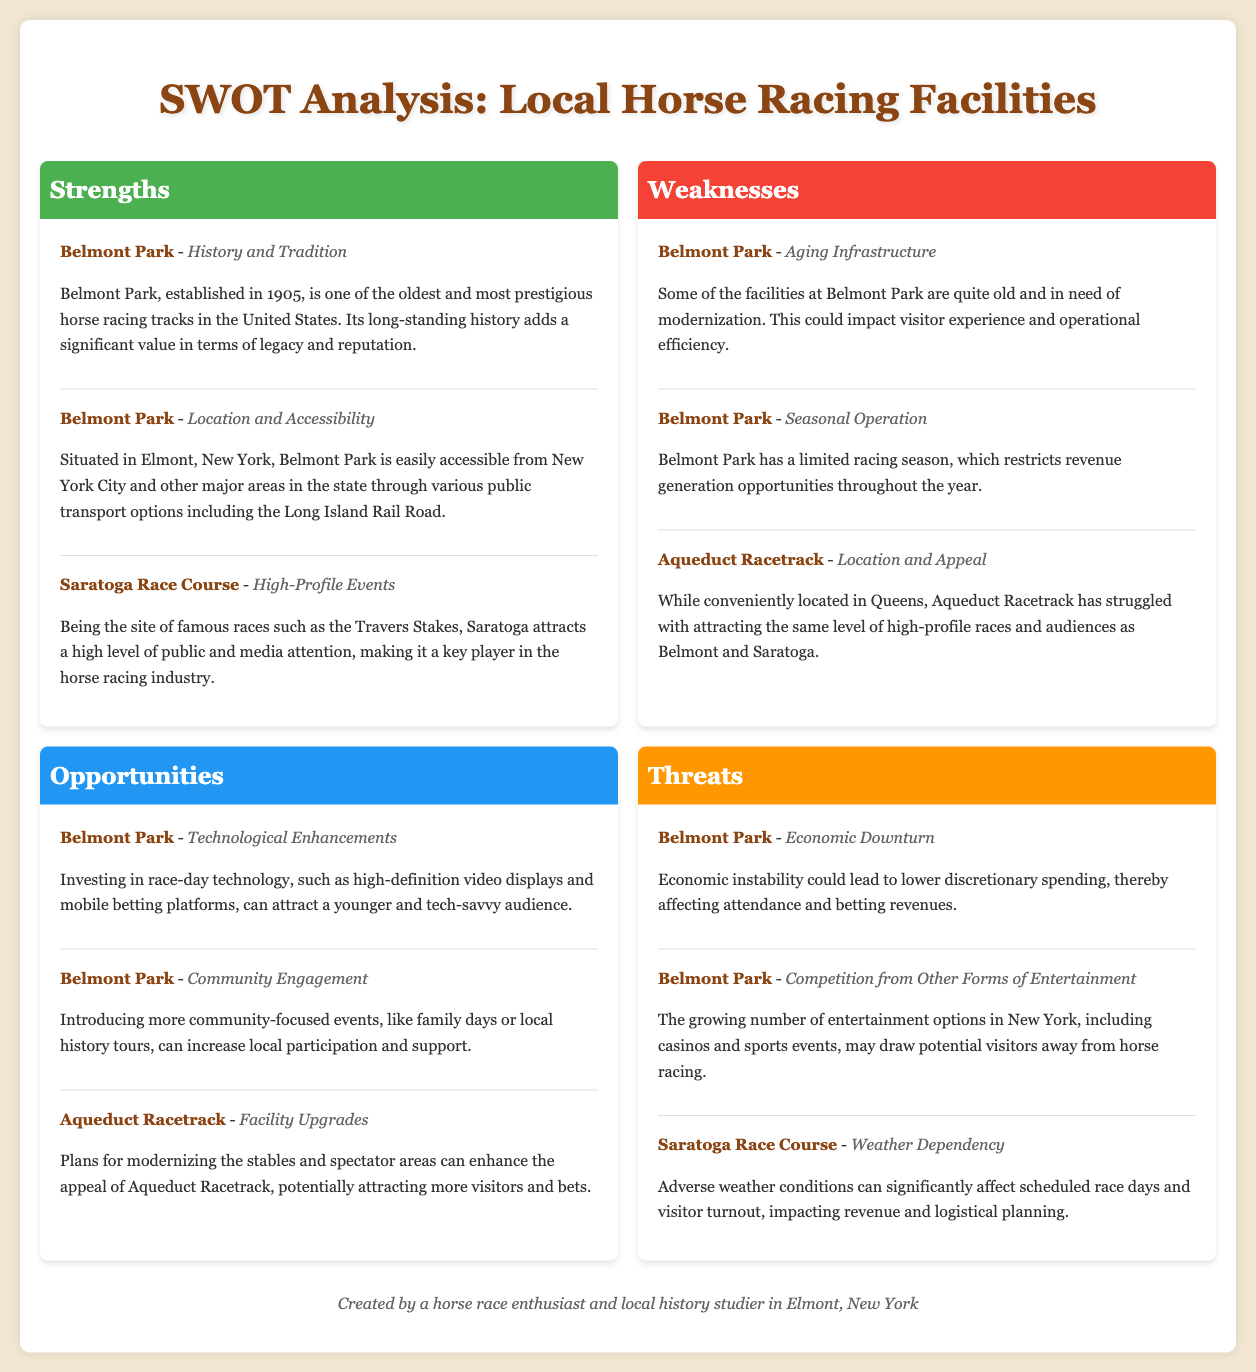What year was Belmont Park established? Belmont Park was established in the year mentioned in the strengths section of the document.
Answer: 1905 What is a major weakness of Belmont Park? The document lists specific weaknesses under Belmont Park, highlighting the need for modernization.
Answer: Aging Infrastructure What high-profile event takes place at Saratoga Race Course? The document specifies a key event that is famous and significant in the horse racing industry.
Answer: Travers Stakes What facility is mentioned as having a limited racing season? The weaknesses section points out this limitation for Belmont Park specifically.
Answer: Belmont Park What opportunity involves community engagement at Belmont Park? The document suggests ways to increase local participation through community-focused events.
Answer: Community Engagement What threat is posed by economic instability? The document outlines potential dangers that may affect horse racing attendance and revenues.
Answer: Lower discretionary spending What improvement is suggested for Aqueduct Racetrack? The opportunities section mentions specific plans for upgrades to enhance visitor appeal.
Answer: Facility Upgrades Which facility is more susceptible to adverse weather conditions? The document identifies threats that can disrupt events specifically at Saratoga Race Course.
Answer: Saratoga Race Course What aspect of Belmont Park's location enhances its accessibility? The strengths section indicates public transport options contributing to its ease of reach.
Answer: Location and Accessibility 